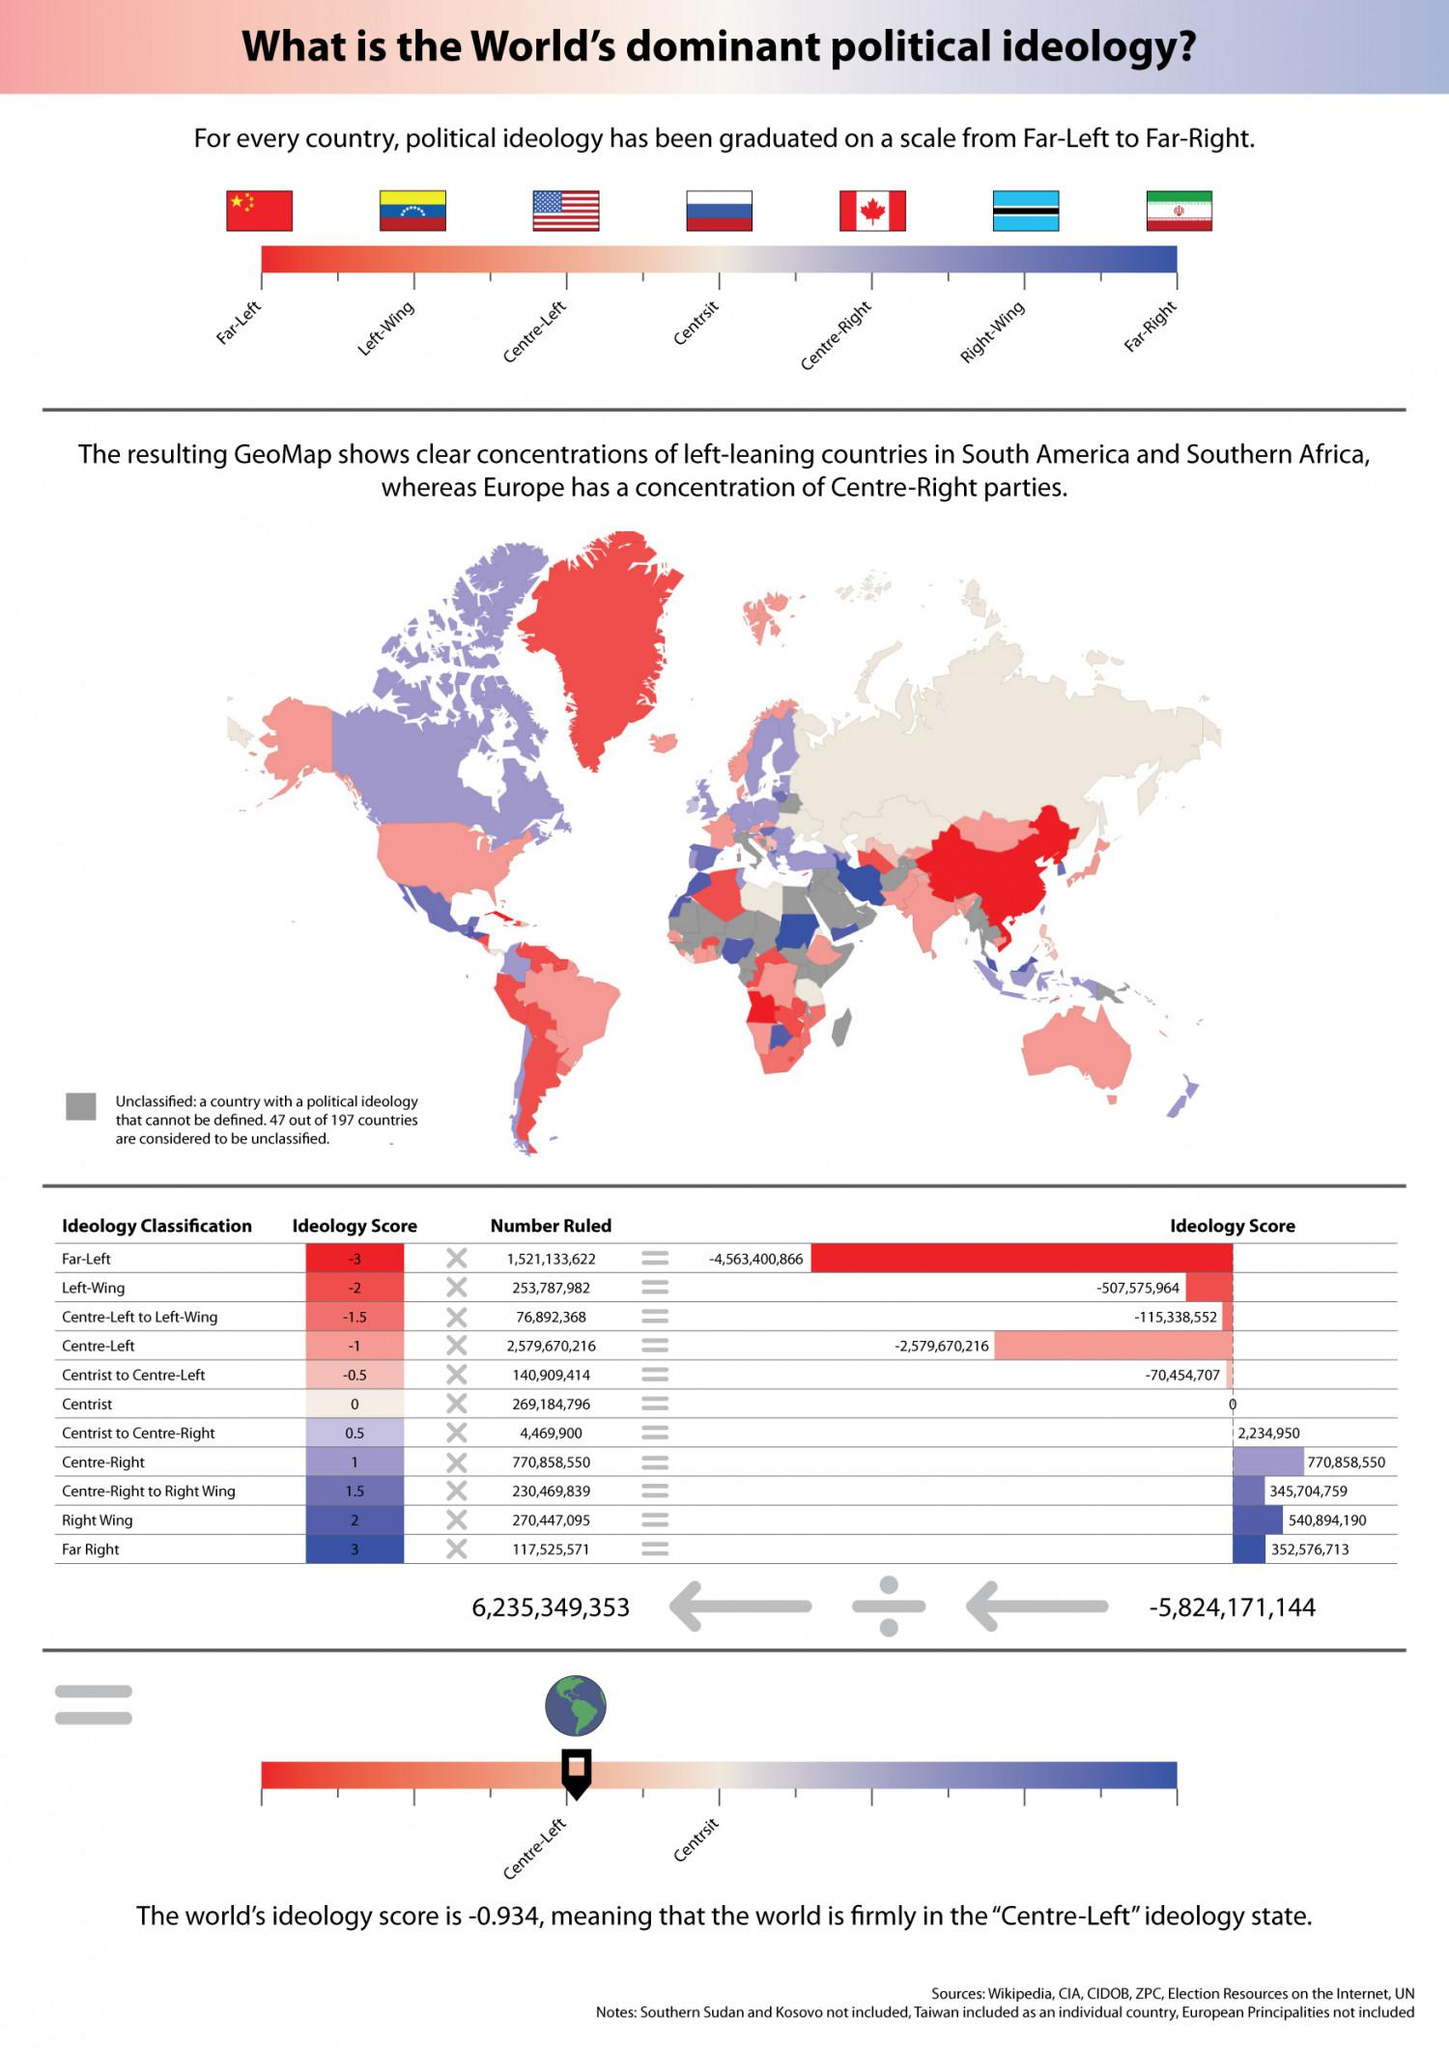Give some essential details in this illustration. The country with left-wing political ideologies is Venezuela, and it is not Iran or the United States. Based on the ideology score provided, it can be declared that China's ideology score is -3. Iran has far-right political ideologies, while Canada and China do not. Russia's political ideology score would be 0 out of 10, reflecting a highly authoritarian government with limited political freedom and human rights abuses. Based on the current ideology score of 2, Botswana's ideology is consistent with a moderate mix of capitalism and government intervention in the economy, with a focus on individual rights and responsibilities. 